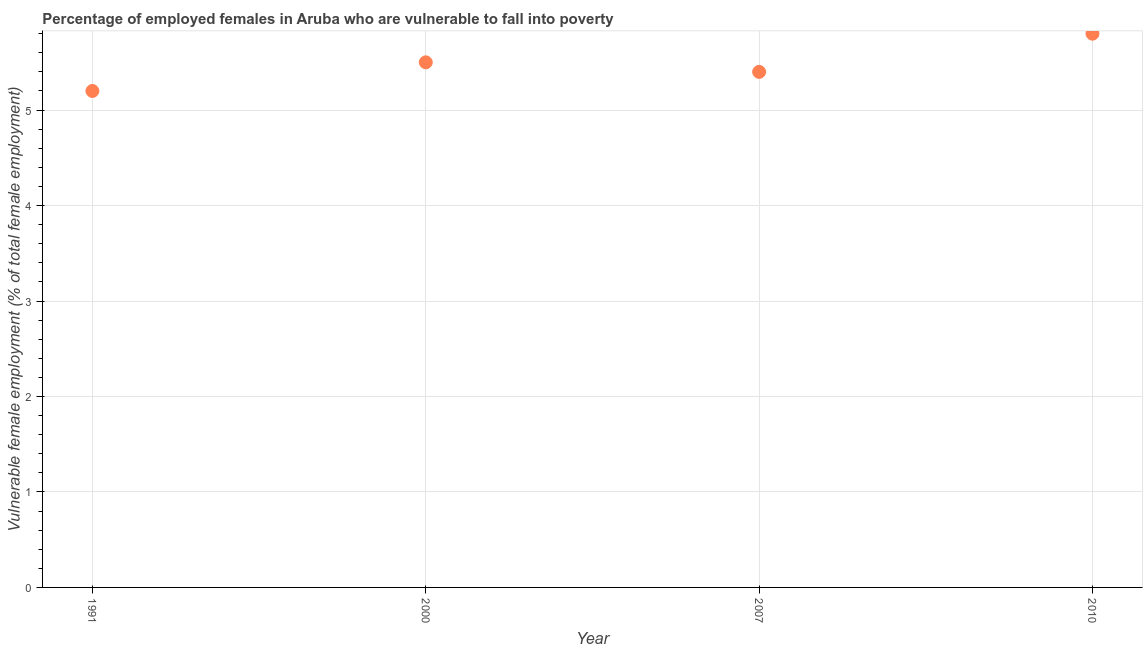What is the percentage of employed females who are vulnerable to fall into poverty in 2010?
Provide a succinct answer. 5.8. Across all years, what is the maximum percentage of employed females who are vulnerable to fall into poverty?
Provide a short and direct response. 5.8. Across all years, what is the minimum percentage of employed females who are vulnerable to fall into poverty?
Give a very brief answer. 5.2. In which year was the percentage of employed females who are vulnerable to fall into poverty maximum?
Provide a short and direct response. 2010. What is the sum of the percentage of employed females who are vulnerable to fall into poverty?
Provide a succinct answer. 21.9. What is the difference between the percentage of employed females who are vulnerable to fall into poverty in 1991 and 2007?
Provide a short and direct response. -0.2. What is the average percentage of employed females who are vulnerable to fall into poverty per year?
Provide a succinct answer. 5.48. What is the median percentage of employed females who are vulnerable to fall into poverty?
Keep it short and to the point. 5.45. In how many years, is the percentage of employed females who are vulnerable to fall into poverty greater than 3.8 %?
Offer a very short reply. 4. What is the ratio of the percentage of employed females who are vulnerable to fall into poverty in 2000 to that in 2007?
Make the answer very short. 1.02. Is the percentage of employed females who are vulnerable to fall into poverty in 2007 less than that in 2010?
Give a very brief answer. Yes. What is the difference between the highest and the second highest percentage of employed females who are vulnerable to fall into poverty?
Your response must be concise. 0.3. What is the difference between the highest and the lowest percentage of employed females who are vulnerable to fall into poverty?
Ensure brevity in your answer.  0.6. Does the percentage of employed females who are vulnerable to fall into poverty monotonically increase over the years?
Make the answer very short. No. How many dotlines are there?
Give a very brief answer. 1. Does the graph contain any zero values?
Ensure brevity in your answer.  No. What is the title of the graph?
Offer a very short reply. Percentage of employed females in Aruba who are vulnerable to fall into poverty. What is the label or title of the X-axis?
Ensure brevity in your answer.  Year. What is the label or title of the Y-axis?
Keep it short and to the point. Vulnerable female employment (% of total female employment). What is the Vulnerable female employment (% of total female employment) in 1991?
Give a very brief answer. 5.2. What is the Vulnerable female employment (% of total female employment) in 2000?
Provide a short and direct response. 5.5. What is the Vulnerable female employment (% of total female employment) in 2007?
Provide a short and direct response. 5.4. What is the Vulnerable female employment (% of total female employment) in 2010?
Offer a very short reply. 5.8. What is the difference between the Vulnerable female employment (% of total female employment) in 1991 and 2000?
Give a very brief answer. -0.3. What is the difference between the Vulnerable female employment (% of total female employment) in 1991 and 2007?
Provide a short and direct response. -0.2. What is the difference between the Vulnerable female employment (% of total female employment) in 2000 and 2007?
Provide a short and direct response. 0.1. What is the ratio of the Vulnerable female employment (% of total female employment) in 1991 to that in 2000?
Make the answer very short. 0.94. What is the ratio of the Vulnerable female employment (% of total female employment) in 1991 to that in 2010?
Your answer should be compact. 0.9. What is the ratio of the Vulnerable female employment (% of total female employment) in 2000 to that in 2007?
Provide a succinct answer. 1.02. What is the ratio of the Vulnerable female employment (% of total female employment) in 2000 to that in 2010?
Ensure brevity in your answer.  0.95. What is the ratio of the Vulnerable female employment (% of total female employment) in 2007 to that in 2010?
Ensure brevity in your answer.  0.93. 